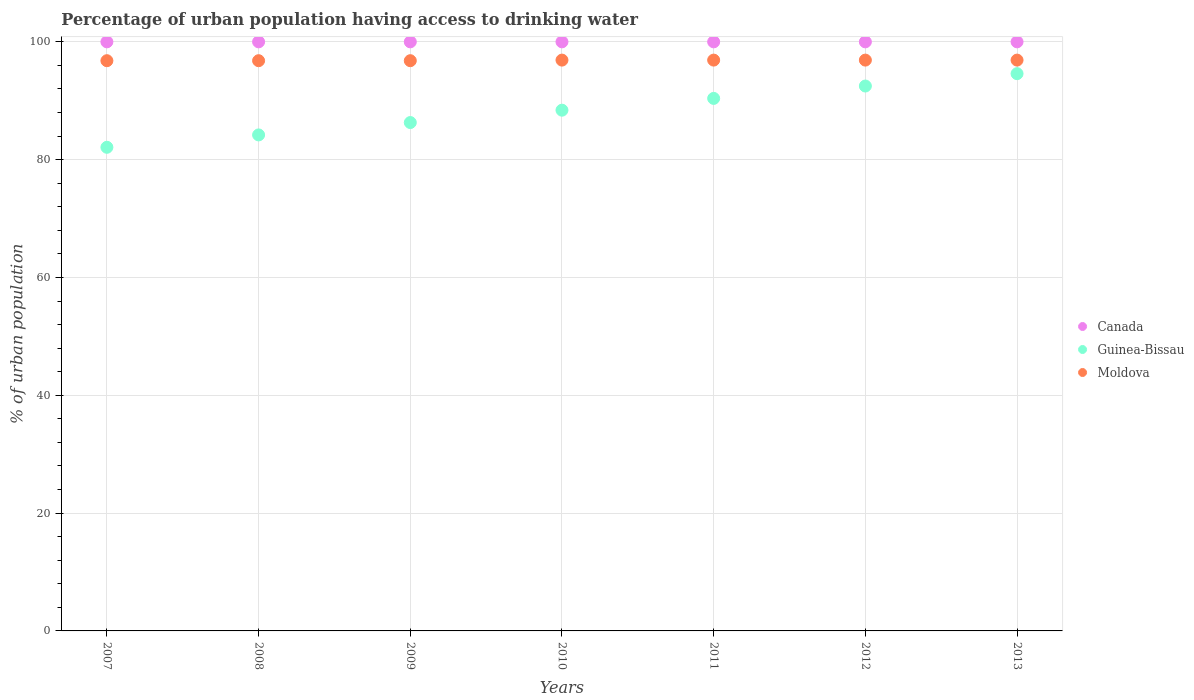What is the percentage of urban population having access to drinking water in Guinea-Bissau in 2012?
Your response must be concise. 92.5. Across all years, what is the maximum percentage of urban population having access to drinking water in Canada?
Make the answer very short. 100. Across all years, what is the minimum percentage of urban population having access to drinking water in Moldova?
Give a very brief answer. 96.8. In which year was the percentage of urban population having access to drinking water in Guinea-Bissau maximum?
Provide a succinct answer. 2013. What is the total percentage of urban population having access to drinking water in Moldova in the graph?
Ensure brevity in your answer.  678. What is the difference between the percentage of urban population having access to drinking water in Moldova in 2007 and that in 2013?
Offer a very short reply. -0.1. What is the difference between the percentage of urban population having access to drinking water in Moldova in 2011 and the percentage of urban population having access to drinking water in Canada in 2012?
Give a very brief answer. -3.1. What is the average percentage of urban population having access to drinking water in Moldova per year?
Your response must be concise. 96.86. In the year 2013, what is the difference between the percentage of urban population having access to drinking water in Moldova and percentage of urban population having access to drinking water in Guinea-Bissau?
Keep it short and to the point. 2.3. What is the difference between the highest and the second highest percentage of urban population having access to drinking water in Moldova?
Provide a short and direct response. 0. What is the difference between the highest and the lowest percentage of urban population having access to drinking water in Moldova?
Keep it short and to the point. 0.1. How many dotlines are there?
Your response must be concise. 3. What is the difference between two consecutive major ticks on the Y-axis?
Ensure brevity in your answer.  20. Are the values on the major ticks of Y-axis written in scientific E-notation?
Keep it short and to the point. No. Does the graph contain any zero values?
Make the answer very short. No. Where does the legend appear in the graph?
Your response must be concise. Center right. What is the title of the graph?
Your response must be concise. Percentage of urban population having access to drinking water. What is the label or title of the X-axis?
Give a very brief answer. Years. What is the label or title of the Y-axis?
Your answer should be very brief. % of urban population. What is the % of urban population in Canada in 2007?
Your answer should be compact. 100. What is the % of urban population of Guinea-Bissau in 2007?
Provide a short and direct response. 82.1. What is the % of urban population of Moldova in 2007?
Keep it short and to the point. 96.8. What is the % of urban population in Guinea-Bissau in 2008?
Keep it short and to the point. 84.2. What is the % of urban population of Moldova in 2008?
Provide a short and direct response. 96.8. What is the % of urban population in Guinea-Bissau in 2009?
Your answer should be very brief. 86.3. What is the % of urban population of Moldova in 2009?
Provide a short and direct response. 96.8. What is the % of urban population in Canada in 2010?
Your response must be concise. 100. What is the % of urban population of Guinea-Bissau in 2010?
Offer a very short reply. 88.4. What is the % of urban population of Moldova in 2010?
Ensure brevity in your answer.  96.9. What is the % of urban population of Guinea-Bissau in 2011?
Give a very brief answer. 90.4. What is the % of urban population of Moldova in 2011?
Make the answer very short. 96.9. What is the % of urban population of Canada in 2012?
Make the answer very short. 100. What is the % of urban population of Guinea-Bissau in 2012?
Keep it short and to the point. 92.5. What is the % of urban population in Moldova in 2012?
Offer a terse response. 96.9. What is the % of urban population in Canada in 2013?
Provide a short and direct response. 100. What is the % of urban population of Guinea-Bissau in 2013?
Make the answer very short. 94.6. What is the % of urban population in Moldova in 2013?
Offer a terse response. 96.9. Across all years, what is the maximum % of urban population of Canada?
Your answer should be very brief. 100. Across all years, what is the maximum % of urban population in Guinea-Bissau?
Provide a succinct answer. 94.6. Across all years, what is the maximum % of urban population of Moldova?
Your answer should be compact. 96.9. Across all years, what is the minimum % of urban population of Guinea-Bissau?
Offer a terse response. 82.1. Across all years, what is the minimum % of urban population of Moldova?
Your answer should be very brief. 96.8. What is the total % of urban population in Canada in the graph?
Your answer should be very brief. 700. What is the total % of urban population in Guinea-Bissau in the graph?
Make the answer very short. 618.5. What is the total % of urban population of Moldova in the graph?
Offer a terse response. 678. What is the difference between the % of urban population of Guinea-Bissau in 2007 and that in 2008?
Provide a succinct answer. -2.1. What is the difference between the % of urban population in Moldova in 2007 and that in 2008?
Offer a very short reply. 0. What is the difference between the % of urban population of Canada in 2007 and that in 2009?
Your answer should be very brief. 0. What is the difference between the % of urban population in Canada in 2007 and that in 2010?
Your response must be concise. 0. What is the difference between the % of urban population of Guinea-Bissau in 2007 and that in 2011?
Offer a terse response. -8.3. What is the difference between the % of urban population of Canada in 2007 and that in 2012?
Keep it short and to the point. 0. What is the difference between the % of urban population of Moldova in 2007 and that in 2012?
Offer a very short reply. -0.1. What is the difference between the % of urban population in Canada in 2007 and that in 2013?
Your answer should be compact. 0. What is the difference between the % of urban population in Guinea-Bissau in 2007 and that in 2013?
Offer a terse response. -12.5. What is the difference between the % of urban population of Moldova in 2007 and that in 2013?
Your response must be concise. -0.1. What is the difference between the % of urban population in Canada in 2008 and that in 2009?
Ensure brevity in your answer.  0. What is the difference between the % of urban population in Moldova in 2008 and that in 2010?
Give a very brief answer. -0.1. What is the difference between the % of urban population in Moldova in 2008 and that in 2011?
Offer a terse response. -0.1. What is the difference between the % of urban population of Guinea-Bissau in 2008 and that in 2012?
Provide a succinct answer. -8.3. What is the difference between the % of urban population of Canada in 2008 and that in 2013?
Your answer should be very brief. 0. What is the difference between the % of urban population in Guinea-Bissau in 2009 and that in 2010?
Provide a short and direct response. -2.1. What is the difference between the % of urban population in Guinea-Bissau in 2009 and that in 2011?
Make the answer very short. -4.1. What is the difference between the % of urban population of Canada in 2009 and that in 2012?
Provide a short and direct response. 0. What is the difference between the % of urban population of Guinea-Bissau in 2009 and that in 2012?
Provide a succinct answer. -6.2. What is the difference between the % of urban population in Moldova in 2009 and that in 2012?
Provide a succinct answer. -0.1. What is the difference between the % of urban population in Canada in 2009 and that in 2013?
Offer a very short reply. 0. What is the difference between the % of urban population in Guinea-Bissau in 2009 and that in 2013?
Give a very brief answer. -8.3. What is the difference between the % of urban population of Canada in 2010 and that in 2011?
Provide a succinct answer. 0. What is the difference between the % of urban population in Canada in 2010 and that in 2012?
Provide a short and direct response. 0. What is the difference between the % of urban population of Guinea-Bissau in 2010 and that in 2012?
Your answer should be very brief. -4.1. What is the difference between the % of urban population of Moldova in 2010 and that in 2012?
Offer a terse response. 0. What is the difference between the % of urban population in Canada in 2010 and that in 2013?
Offer a terse response. 0. What is the difference between the % of urban population of Guinea-Bissau in 2010 and that in 2013?
Provide a short and direct response. -6.2. What is the difference between the % of urban population in Moldova in 2010 and that in 2013?
Your answer should be compact. 0. What is the difference between the % of urban population in Canada in 2011 and that in 2012?
Your answer should be very brief. 0. What is the difference between the % of urban population in Guinea-Bissau in 2011 and that in 2012?
Offer a very short reply. -2.1. What is the difference between the % of urban population of Canada in 2011 and that in 2013?
Your response must be concise. 0. What is the difference between the % of urban population in Canada in 2012 and that in 2013?
Provide a short and direct response. 0. What is the difference between the % of urban population of Guinea-Bissau in 2012 and that in 2013?
Offer a very short reply. -2.1. What is the difference between the % of urban population in Canada in 2007 and the % of urban population in Guinea-Bissau in 2008?
Offer a terse response. 15.8. What is the difference between the % of urban population in Guinea-Bissau in 2007 and the % of urban population in Moldova in 2008?
Your answer should be very brief. -14.7. What is the difference between the % of urban population of Canada in 2007 and the % of urban population of Guinea-Bissau in 2009?
Your response must be concise. 13.7. What is the difference between the % of urban population of Guinea-Bissau in 2007 and the % of urban population of Moldova in 2009?
Ensure brevity in your answer.  -14.7. What is the difference between the % of urban population of Guinea-Bissau in 2007 and the % of urban population of Moldova in 2010?
Your answer should be very brief. -14.8. What is the difference between the % of urban population of Canada in 2007 and the % of urban population of Moldova in 2011?
Make the answer very short. 3.1. What is the difference between the % of urban population of Guinea-Bissau in 2007 and the % of urban population of Moldova in 2011?
Provide a succinct answer. -14.8. What is the difference between the % of urban population of Canada in 2007 and the % of urban population of Moldova in 2012?
Your answer should be compact. 3.1. What is the difference between the % of urban population of Guinea-Bissau in 2007 and the % of urban population of Moldova in 2012?
Your answer should be very brief. -14.8. What is the difference between the % of urban population in Canada in 2007 and the % of urban population in Moldova in 2013?
Make the answer very short. 3.1. What is the difference between the % of urban population of Guinea-Bissau in 2007 and the % of urban population of Moldova in 2013?
Give a very brief answer. -14.8. What is the difference between the % of urban population in Canada in 2008 and the % of urban population in Guinea-Bissau in 2009?
Ensure brevity in your answer.  13.7. What is the difference between the % of urban population in Canada in 2008 and the % of urban population in Moldova in 2009?
Ensure brevity in your answer.  3.2. What is the difference between the % of urban population of Canada in 2008 and the % of urban population of Moldova in 2011?
Ensure brevity in your answer.  3.1. What is the difference between the % of urban population of Canada in 2008 and the % of urban population of Guinea-Bissau in 2013?
Your answer should be compact. 5.4. What is the difference between the % of urban population of Canada in 2008 and the % of urban population of Moldova in 2013?
Offer a very short reply. 3.1. What is the difference between the % of urban population in Canada in 2009 and the % of urban population in Guinea-Bissau in 2010?
Your answer should be compact. 11.6. What is the difference between the % of urban population in Canada in 2009 and the % of urban population in Moldova in 2010?
Offer a terse response. 3.1. What is the difference between the % of urban population of Guinea-Bissau in 2009 and the % of urban population of Moldova in 2010?
Your answer should be very brief. -10.6. What is the difference between the % of urban population in Canada in 2009 and the % of urban population in Guinea-Bissau in 2012?
Offer a terse response. 7.5. What is the difference between the % of urban population in Canada in 2009 and the % of urban population in Moldova in 2012?
Provide a succinct answer. 3.1. What is the difference between the % of urban population of Canada in 2010 and the % of urban population of Moldova in 2011?
Your answer should be very brief. 3.1. What is the difference between the % of urban population in Canada in 2010 and the % of urban population in Guinea-Bissau in 2012?
Offer a terse response. 7.5. What is the difference between the % of urban population of Canada in 2010 and the % of urban population of Moldova in 2012?
Keep it short and to the point. 3.1. What is the difference between the % of urban population in Guinea-Bissau in 2010 and the % of urban population in Moldova in 2012?
Provide a succinct answer. -8.5. What is the difference between the % of urban population of Canada in 2010 and the % of urban population of Guinea-Bissau in 2013?
Your answer should be very brief. 5.4. What is the difference between the % of urban population in Canada in 2011 and the % of urban population in Guinea-Bissau in 2012?
Your response must be concise. 7.5. What is the difference between the % of urban population of Canada in 2011 and the % of urban population of Moldova in 2012?
Make the answer very short. 3.1. What is the difference between the % of urban population of Canada in 2011 and the % of urban population of Moldova in 2013?
Provide a succinct answer. 3.1. What is the difference between the % of urban population of Canada in 2012 and the % of urban population of Guinea-Bissau in 2013?
Offer a terse response. 5.4. What is the difference between the % of urban population in Canada in 2012 and the % of urban population in Moldova in 2013?
Your answer should be very brief. 3.1. What is the difference between the % of urban population of Guinea-Bissau in 2012 and the % of urban population of Moldova in 2013?
Give a very brief answer. -4.4. What is the average % of urban population of Canada per year?
Your answer should be very brief. 100. What is the average % of urban population of Guinea-Bissau per year?
Your answer should be very brief. 88.36. What is the average % of urban population in Moldova per year?
Your answer should be very brief. 96.86. In the year 2007, what is the difference between the % of urban population of Canada and % of urban population of Moldova?
Your answer should be compact. 3.2. In the year 2007, what is the difference between the % of urban population of Guinea-Bissau and % of urban population of Moldova?
Offer a very short reply. -14.7. In the year 2009, what is the difference between the % of urban population in Canada and % of urban population in Moldova?
Your answer should be compact. 3.2. In the year 2009, what is the difference between the % of urban population in Guinea-Bissau and % of urban population in Moldova?
Your response must be concise. -10.5. In the year 2011, what is the difference between the % of urban population of Canada and % of urban population of Guinea-Bissau?
Make the answer very short. 9.6. In the year 2011, what is the difference between the % of urban population of Guinea-Bissau and % of urban population of Moldova?
Ensure brevity in your answer.  -6.5. In the year 2012, what is the difference between the % of urban population in Canada and % of urban population in Moldova?
Your answer should be compact. 3.1. In the year 2013, what is the difference between the % of urban population in Canada and % of urban population in Guinea-Bissau?
Ensure brevity in your answer.  5.4. In the year 2013, what is the difference between the % of urban population in Canada and % of urban population in Moldova?
Offer a terse response. 3.1. In the year 2013, what is the difference between the % of urban population of Guinea-Bissau and % of urban population of Moldova?
Make the answer very short. -2.3. What is the ratio of the % of urban population in Canada in 2007 to that in 2008?
Provide a short and direct response. 1. What is the ratio of the % of urban population of Guinea-Bissau in 2007 to that in 2008?
Ensure brevity in your answer.  0.98. What is the ratio of the % of urban population in Moldova in 2007 to that in 2008?
Your answer should be compact. 1. What is the ratio of the % of urban population in Canada in 2007 to that in 2009?
Give a very brief answer. 1. What is the ratio of the % of urban population in Guinea-Bissau in 2007 to that in 2009?
Provide a succinct answer. 0.95. What is the ratio of the % of urban population of Guinea-Bissau in 2007 to that in 2010?
Your response must be concise. 0.93. What is the ratio of the % of urban population in Moldova in 2007 to that in 2010?
Keep it short and to the point. 1. What is the ratio of the % of urban population in Canada in 2007 to that in 2011?
Give a very brief answer. 1. What is the ratio of the % of urban population of Guinea-Bissau in 2007 to that in 2011?
Give a very brief answer. 0.91. What is the ratio of the % of urban population in Guinea-Bissau in 2007 to that in 2012?
Provide a short and direct response. 0.89. What is the ratio of the % of urban population of Guinea-Bissau in 2007 to that in 2013?
Give a very brief answer. 0.87. What is the ratio of the % of urban population of Moldova in 2007 to that in 2013?
Offer a terse response. 1. What is the ratio of the % of urban population of Guinea-Bissau in 2008 to that in 2009?
Keep it short and to the point. 0.98. What is the ratio of the % of urban population in Moldova in 2008 to that in 2009?
Ensure brevity in your answer.  1. What is the ratio of the % of urban population in Canada in 2008 to that in 2010?
Give a very brief answer. 1. What is the ratio of the % of urban population in Guinea-Bissau in 2008 to that in 2010?
Your answer should be very brief. 0.95. What is the ratio of the % of urban population in Moldova in 2008 to that in 2010?
Offer a very short reply. 1. What is the ratio of the % of urban population of Canada in 2008 to that in 2011?
Offer a terse response. 1. What is the ratio of the % of urban population of Guinea-Bissau in 2008 to that in 2011?
Ensure brevity in your answer.  0.93. What is the ratio of the % of urban population in Moldova in 2008 to that in 2011?
Give a very brief answer. 1. What is the ratio of the % of urban population in Guinea-Bissau in 2008 to that in 2012?
Offer a very short reply. 0.91. What is the ratio of the % of urban population in Moldova in 2008 to that in 2012?
Ensure brevity in your answer.  1. What is the ratio of the % of urban population in Guinea-Bissau in 2008 to that in 2013?
Your answer should be very brief. 0.89. What is the ratio of the % of urban population of Canada in 2009 to that in 2010?
Provide a succinct answer. 1. What is the ratio of the % of urban population in Guinea-Bissau in 2009 to that in 2010?
Provide a short and direct response. 0.98. What is the ratio of the % of urban population in Moldova in 2009 to that in 2010?
Keep it short and to the point. 1. What is the ratio of the % of urban population in Guinea-Bissau in 2009 to that in 2011?
Keep it short and to the point. 0.95. What is the ratio of the % of urban population of Guinea-Bissau in 2009 to that in 2012?
Offer a terse response. 0.93. What is the ratio of the % of urban population in Moldova in 2009 to that in 2012?
Make the answer very short. 1. What is the ratio of the % of urban population in Guinea-Bissau in 2009 to that in 2013?
Your answer should be compact. 0.91. What is the ratio of the % of urban population of Moldova in 2009 to that in 2013?
Your answer should be very brief. 1. What is the ratio of the % of urban population in Canada in 2010 to that in 2011?
Provide a short and direct response. 1. What is the ratio of the % of urban population in Guinea-Bissau in 2010 to that in 2011?
Ensure brevity in your answer.  0.98. What is the ratio of the % of urban population of Guinea-Bissau in 2010 to that in 2012?
Give a very brief answer. 0.96. What is the ratio of the % of urban population in Guinea-Bissau in 2010 to that in 2013?
Your answer should be very brief. 0.93. What is the ratio of the % of urban population in Canada in 2011 to that in 2012?
Give a very brief answer. 1. What is the ratio of the % of urban population in Guinea-Bissau in 2011 to that in 2012?
Your response must be concise. 0.98. What is the ratio of the % of urban population of Canada in 2011 to that in 2013?
Ensure brevity in your answer.  1. What is the ratio of the % of urban population of Guinea-Bissau in 2011 to that in 2013?
Give a very brief answer. 0.96. What is the ratio of the % of urban population of Guinea-Bissau in 2012 to that in 2013?
Provide a succinct answer. 0.98. What is the ratio of the % of urban population of Moldova in 2012 to that in 2013?
Ensure brevity in your answer.  1. What is the difference between the highest and the lowest % of urban population of Guinea-Bissau?
Offer a terse response. 12.5. 